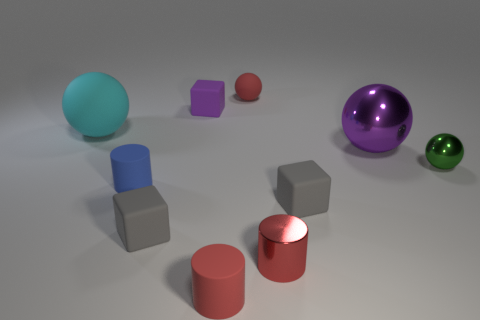What shapes can you identify in the image? In the image, there are spheres, cubes, and cylinders. Specifically, there are two spheres, three cubes, and three cylinders.  Could you tell me about the lighting in the scene? The lighting in the scene appears to be soft and diffused, possibly from an overhead source. It creates gentle shadows that help to define the shapes of the objects and gives the scene a calm, serene look. 